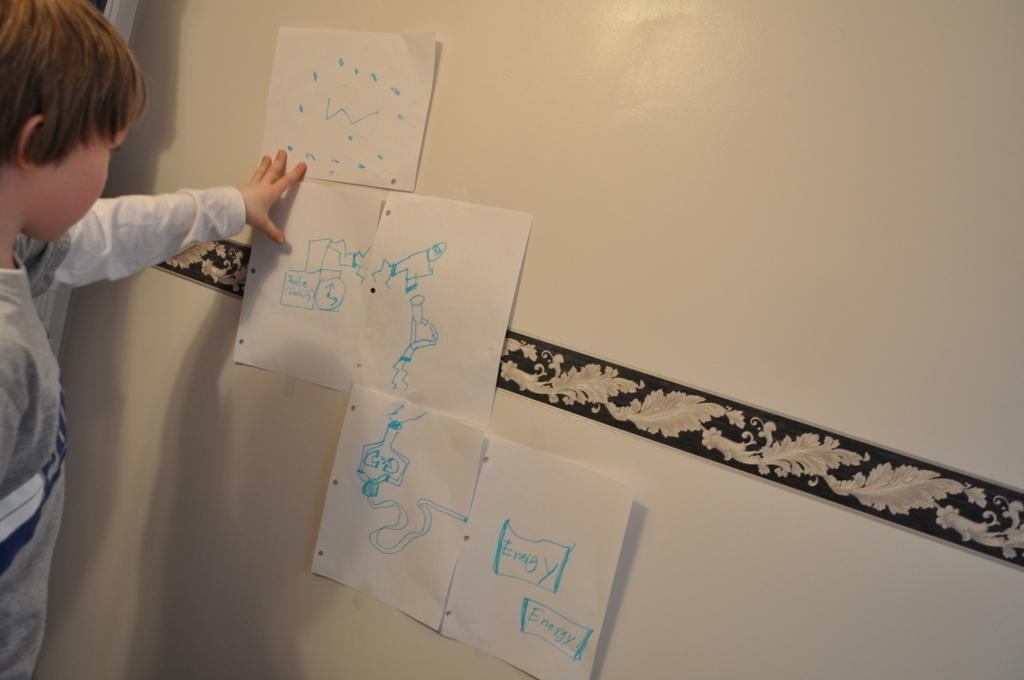Provide a one-sentence caption for the provided image. A child looks at pieces of paper with a diagram that says energy at the end of the chart. 